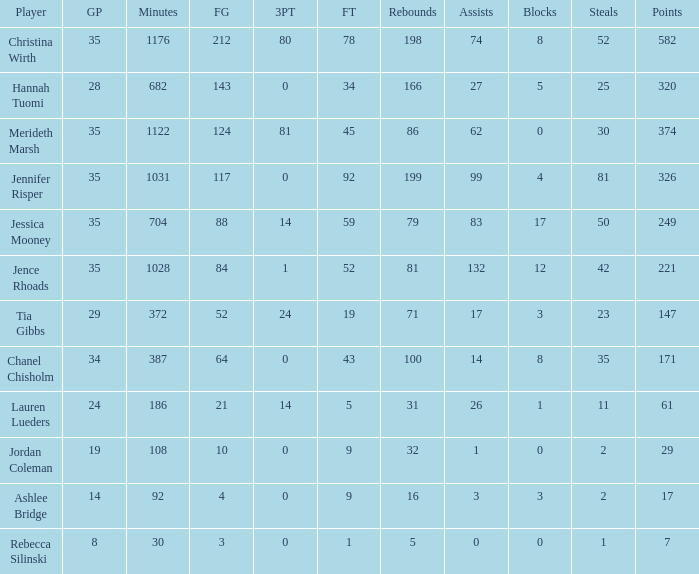How many obstructions happened in the game with 198 rebounds? 8.0. 